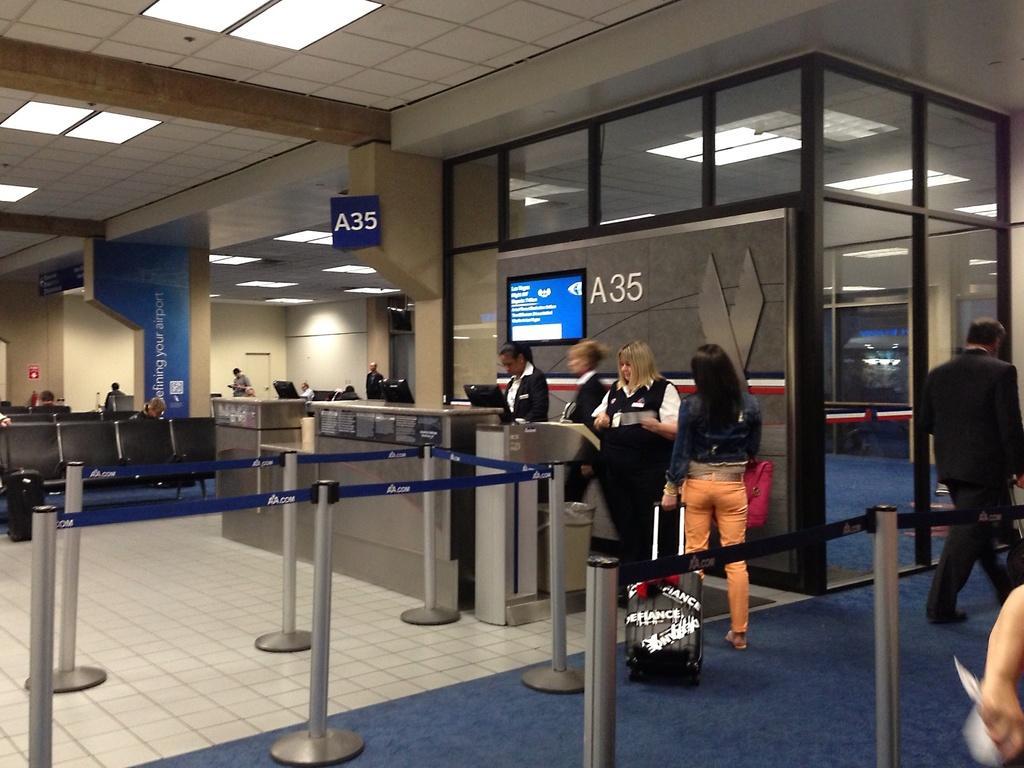Describe this image in one or two sentences. I think this picture is taken in an airport. In the center, there are four women, three of them are wearing black blazers. Another woman is wearing blue jacket and orange trousers and she is holding a bag. At the bottom, there are iron poles. Towards the right, there is a man wearing a black blazer. Towards the left there are seats and pillars. On the top, there is a ceiling with lights. 